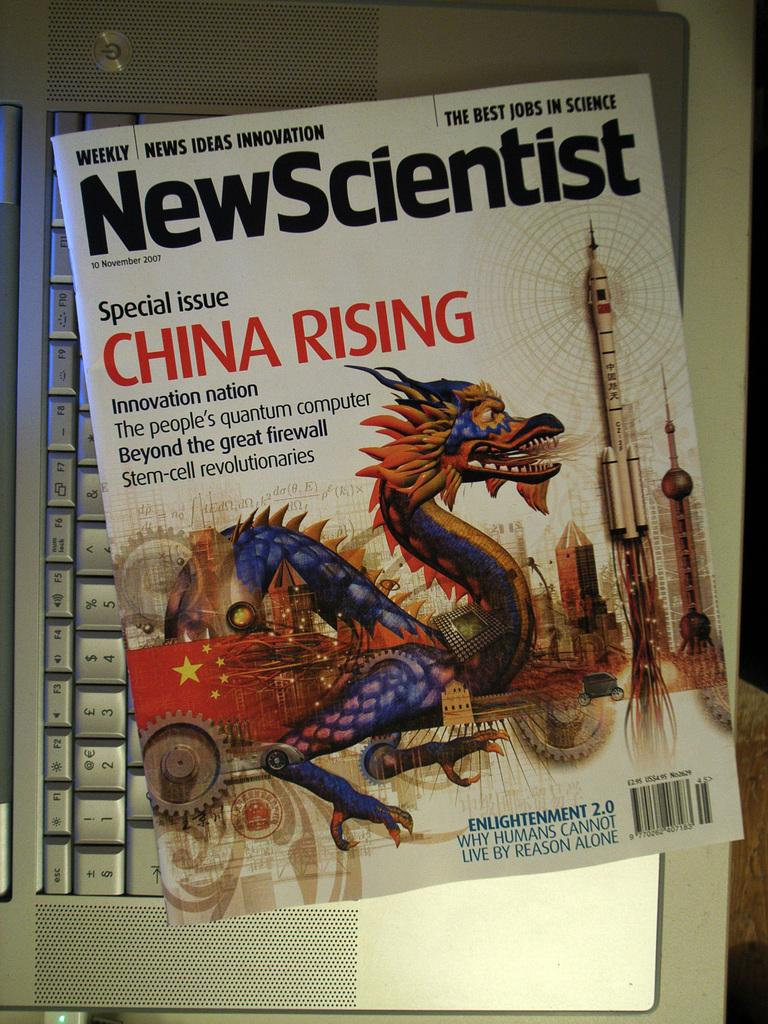<image>
Give a short and clear explanation of the subsequent image. A New Scientist magazine cover showing a dragon and mentioning China Rising. 